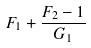Convert formula to latex. <formula><loc_0><loc_0><loc_500><loc_500>F _ { 1 } + \frac { F _ { 2 } - 1 } { G _ { 1 } }</formula> 